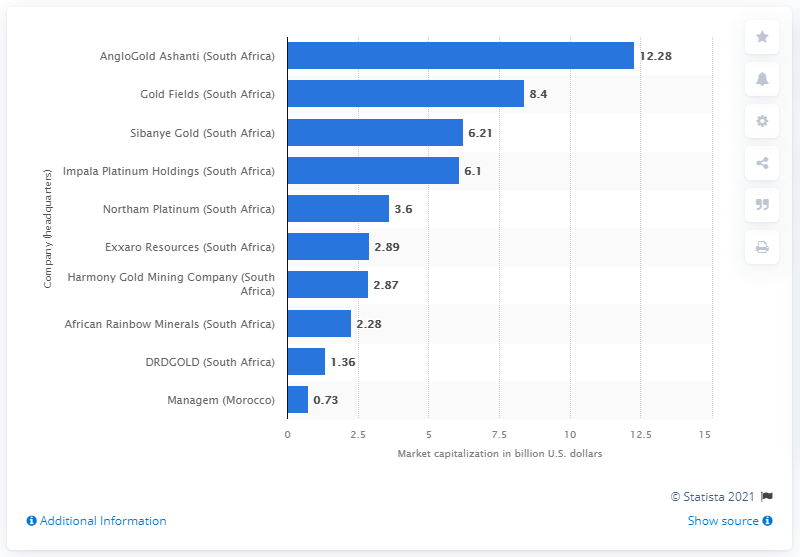List a handful of essential elements in this visual. As of July 2020, the market capitalization of AngloGold Ashanti was 12.28 billion. 